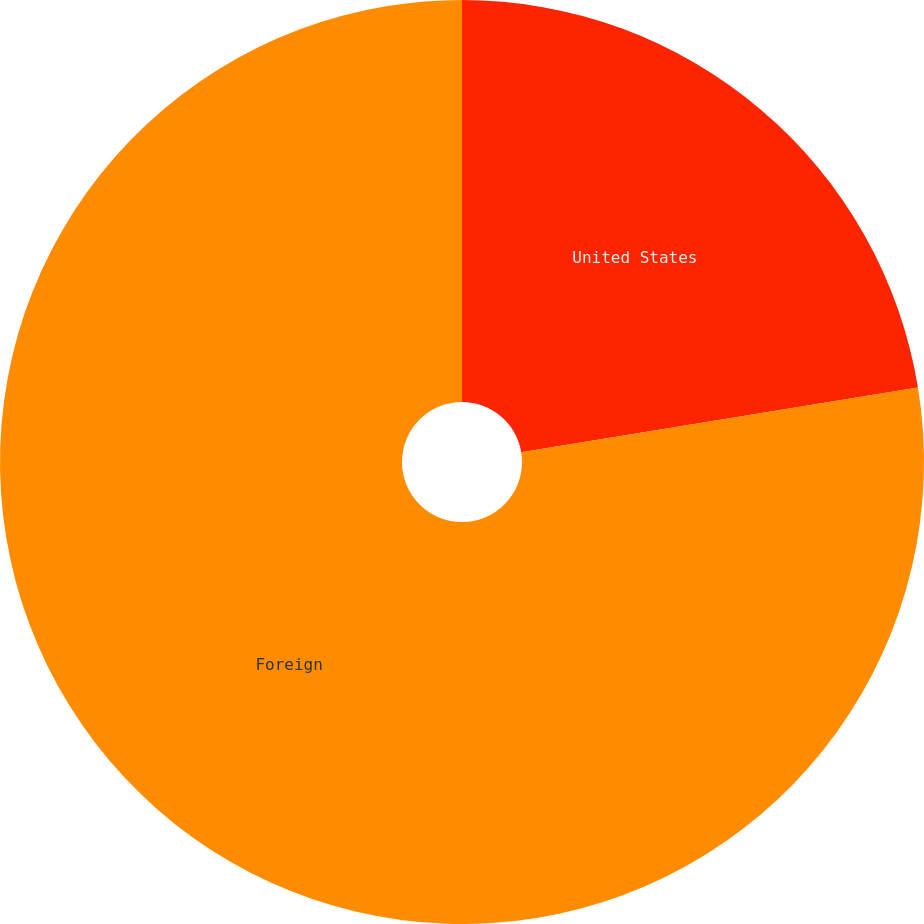Convert chart to OTSL. <chart><loc_0><loc_0><loc_500><loc_500><pie_chart><fcel>United States<fcel>Foreign<nl><fcel>22.42%<fcel>77.58%<nl></chart> 